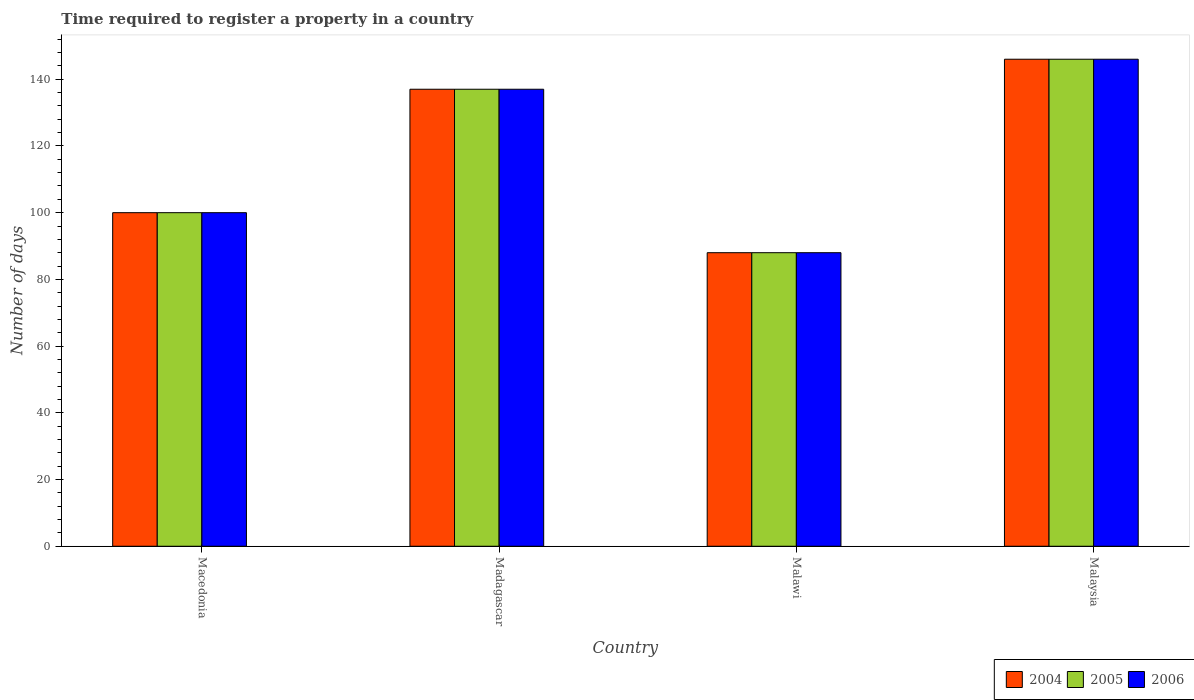How many different coloured bars are there?
Give a very brief answer. 3. How many groups of bars are there?
Offer a very short reply. 4. Are the number of bars per tick equal to the number of legend labels?
Offer a terse response. Yes. How many bars are there on the 2nd tick from the right?
Offer a very short reply. 3. What is the label of the 4th group of bars from the left?
Make the answer very short. Malaysia. In how many cases, is the number of bars for a given country not equal to the number of legend labels?
Your answer should be very brief. 0. What is the number of days required to register a property in 2005 in Malaysia?
Make the answer very short. 146. Across all countries, what is the maximum number of days required to register a property in 2006?
Your answer should be compact. 146. Across all countries, what is the minimum number of days required to register a property in 2006?
Give a very brief answer. 88. In which country was the number of days required to register a property in 2006 maximum?
Offer a very short reply. Malaysia. In which country was the number of days required to register a property in 2005 minimum?
Give a very brief answer. Malawi. What is the total number of days required to register a property in 2006 in the graph?
Give a very brief answer. 471. What is the difference between the number of days required to register a property in 2006 in Macedonia and that in Malaysia?
Your answer should be compact. -46. What is the difference between the number of days required to register a property in 2005 in Malawi and the number of days required to register a property in 2006 in Macedonia?
Make the answer very short. -12. What is the average number of days required to register a property in 2005 per country?
Ensure brevity in your answer.  117.75. What is the difference between the number of days required to register a property of/in 2004 and number of days required to register a property of/in 2005 in Macedonia?
Your answer should be compact. 0. What is the ratio of the number of days required to register a property in 2006 in Macedonia to that in Malawi?
Your response must be concise. 1.14. Is the number of days required to register a property in 2006 in Madagascar less than that in Malawi?
Ensure brevity in your answer.  No. Is the difference between the number of days required to register a property in 2004 in Macedonia and Madagascar greater than the difference between the number of days required to register a property in 2005 in Macedonia and Madagascar?
Give a very brief answer. No. What is the difference between the highest and the second highest number of days required to register a property in 2005?
Provide a succinct answer. -9. What is the difference between the highest and the lowest number of days required to register a property in 2005?
Offer a terse response. 58. In how many countries, is the number of days required to register a property in 2004 greater than the average number of days required to register a property in 2004 taken over all countries?
Keep it short and to the point. 2. Is it the case that in every country, the sum of the number of days required to register a property in 2006 and number of days required to register a property in 2004 is greater than the number of days required to register a property in 2005?
Offer a very short reply. Yes. Are all the bars in the graph horizontal?
Provide a succinct answer. No. How many countries are there in the graph?
Make the answer very short. 4. Does the graph contain any zero values?
Your response must be concise. No. How are the legend labels stacked?
Make the answer very short. Horizontal. What is the title of the graph?
Give a very brief answer. Time required to register a property in a country. Does "1978" appear as one of the legend labels in the graph?
Your answer should be very brief. No. What is the label or title of the X-axis?
Offer a very short reply. Country. What is the label or title of the Y-axis?
Keep it short and to the point. Number of days. What is the Number of days in 2004 in Macedonia?
Your answer should be very brief. 100. What is the Number of days of 2004 in Madagascar?
Your answer should be very brief. 137. What is the Number of days of 2005 in Madagascar?
Give a very brief answer. 137. What is the Number of days in 2006 in Madagascar?
Provide a short and direct response. 137. What is the Number of days of 2004 in Malawi?
Provide a succinct answer. 88. What is the Number of days in 2005 in Malawi?
Keep it short and to the point. 88. What is the Number of days of 2004 in Malaysia?
Your answer should be compact. 146. What is the Number of days of 2005 in Malaysia?
Provide a short and direct response. 146. What is the Number of days of 2006 in Malaysia?
Provide a short and direct response. 146. Across all countries, what is the maximum Number of days of 2004?
Offer a terse response. 146. Across all countries, what is the maximum Number of days of 2005?
Offer a terse response. 146. Across all countries, what is the maximum Number of days in 2006?
Ensure brevity in your answer.  146. Across all countries, what is the minimum Number of days of 2005?
Offer a very short reply. 88. Across all countries, what is the minimum Number of days of 2006?
Offer a terse response. 88. What is the total Number of days of 2004 in the graph?
Offer a terse response. 471. What is the total Number of days in 2005 in the graph?
Offer a very short reply. 471. What is the total Number of days in 2006 in the graph?
Provide a short and direct response. 471. What is the difference between the Number of days in 2004 in Macedonia and that in Madagascar?
Your answer should be compact. -37. What is the difference between the Number of days in 2005 in Macedonia and that in Madagascar?
Give a very brief answer. -37. What is the difference between the Number of days of 2006 in Macedonia and that in Madagascar?
Provide a succinct answer. -37. What is the difference between the Number of days of 2005 in Macedonia and that in Malawi?
Your response must be concise. 12. What is the difference between the Number of days in 2004 in Macedonia and that in Malaysia?
Your response must be concise. -46. What is the difference between the Number of days of 2005 in Macedonia and that in Malaysia?
Give a very brief answer. -46. What is the difference between the Number of days of 2006 in Macedonia and that in Malaysia?
Keep it short and to the point. -46. What is the difference between the Number of days of 2004 in Madagascar and that in Malawi?
Your answer should be very brief. 49. What is the difference between the Number of days of 2005 in Madagascar and that in Malaysia?
Give a very brief answer. -9. What is the difference between the Number of days in 2004 in Malawi and that in Malaysia?
Offer a terse response. -58. What is the difference between the Number of days of 2005 in Malawi and that in Malaysia?
Make the answer very short. -58. What is the difference between the Number of days in 2006 in Malawi and that in Malaysia?
Offer a terse response. -58. What is the difference between the Number of days in 2004 in Macedonia and the Number of days in 2005 in Madagascar?
Your answer should be compact. -37. What is the difference between the Number of days of 2004 in Macedonia and the Number of days of 2006 in Madagascar?
Provide a succinct answer. -37. What is the difference between the Number of days in 2005 in Macedonia and the Number of days in 2006 in Madagascar?
Make the answer very short. -37. What is the difference between the Number of days in 2004 in Macedonia and the Number of days in 2005 in Malawi?
Offer a very short reply. 12. What is the difference between the Number of days of 2004 in Macedonia and the Number of days of 2005 in Malaysia?
Provide a short and direct response. -46. What is the difference between the Number of days of 2004 in Macedonia and the Number of days of 2006 in Malaysia?
Provide a short and direct response. -46. What is the difference between the Number of days of 2005 in Macedonia and the Number of days of 2006 in Malaysia?
Offer a very short reply. -46. What is the difference between the Number of days of 2004 in Madagascar and the Number of days of 2006 in Malawi?
Give a very brief answer. 49. What is the difference between the Number of days of 2004 in Madagascar and the Number of days of 2005 in Malaysia?
Offer a very short reply. -9. What is the difference between the Number of days of 2004 in Madagascar and the Number of days of 2006 in Malaysia?
Your answer should be compact. -9. What is the difference between the Number of days of 2004 in Malawi and the Number of days of 2005 in Malaysia?
Provide a succinct answer. -58. What is the difference between the Number of days in 2004 in Malawi and the Number of days in 2006 in Malaysia?
Give a very brief answer. -58. What is the difference between the Number of days of 2005 in Malawi and the Number of days of 2006 in Malaysia?
Your answer should be compact. -58. What is the average Number of days in 2004 per country?
Provide a short and direct response. 117.75. What is the average Number of days in 2005 per country?
Provide a succinct answer. 117.75. What is the average Number of days of 2006 per country?
Your answer should be very brief. 117.75. What is the difference between the Number of days in 2004 and Number of days in 2006 in Macedonia?
Your response must be concise. 0. What is the difference between the Number of days in 2005 and Number of days in 2006 in Madagascar?
Offer a very short reply. 0. What is the difference between the Number of days of 2004 and Number of days of 2005 in Malawi?
Offer a terse response. 0. What is the difference between the Number of days of 2004 and Number of days of 2006 in Malawi?
Give a very brief answer. 0. What is the difference between the Number of days in 2005 and Number of days in 2006 in Malawi?
Your answer should be very brief. 0. What is the difference between the Number of days in 2004 and Number of days in 2005 in Malaysia?
Ensure brevity in your answer.  0. What is the difference between the Number of days of 2004 and Number of days of 2006 in Malaysia?
Provide a succinct answer. 0. What is the difference between the Number of days of 2005 and Number of days of 2006 in Malaysia?
Provide a short and direct response. 0. What is the ratio of the Number of days of 2004 in Macedonia to that in Madagascar?
Your answer should be compact. 0.73. What is the ratio of the Number of days in 2005 in Macedonia to that in Madagascar?
Keep it short and to the point. 0.73. What is the ratio of the Number of days of 2006 in Macedonia to that in Madagascar?
Keep it short and to the point. 0.73. What is the ratio of the Number of days of 2004 in Macedonia to that in Malawi?
Offer a terse response. 1.14. What is the ratio of the Number of days of 2005 in Macedonia to that in Malawi?
Give a very brief answer. 1.14. What is the ratio of the Number of days of 2006 in Macedonia to that in Malawi?
Offer a terse response. 1.14. What is the ratio of the Number of days of 2004 in Macedonia to that in Malaysia?
Offer a very short reply. 0.68. What is the ratio of the Number of days in 2005 in Macedonia to that in Malaysia?
Give a very brief answer. 0.68. What is the ratio of the Number of days in 2006 in Macedonia to that in Malaysia?
Provide a short and direct response. 0.68. What is the ratio of the Number of days in 2004 in Madagascar to that in Malawi?
Give a very brief answer. 1.56. What is the ratio of the Number of days of 2005 in Madagascar to that in Malawi?
Provide a short and direct response. 1.56. What is the ratio of the Number of days of 2006 in Madagascar to that in Malawi?
Offer a terse response. 1.56. What is the ratio of the Number of days of 2004 in Madagascar to that in Malaysia?
Your response must be concise. 0.94. What is the ratio of the Number of days of 2005 in Madagascar to that in Malaysia?
Make the answer very short. 0.94. What is the ratio of the Number of days of 2006 in Madagascar to that in Malaysia?
Your response must be concise. 0.94. What is the ratio of the Number of days in 2004 in Malawi to that in Malaysia?
Provide a succinct answer. 0.6. What is the ratio of the Number of days in 2005 in Malawi to that in Malaysia?
Give a very brief answer. 0.6. What is the ratio of the Number of days of 2006 in Malawi to that in Malaysia?
Make the answer very short. 0.6. What is the difference between the highest and the lowest Number of days of 2004?
Ensure brevity in your answer.  58. What is the difference between the highest and the lowest Number of days of 2005?
Provide a succinct answer. 58. 